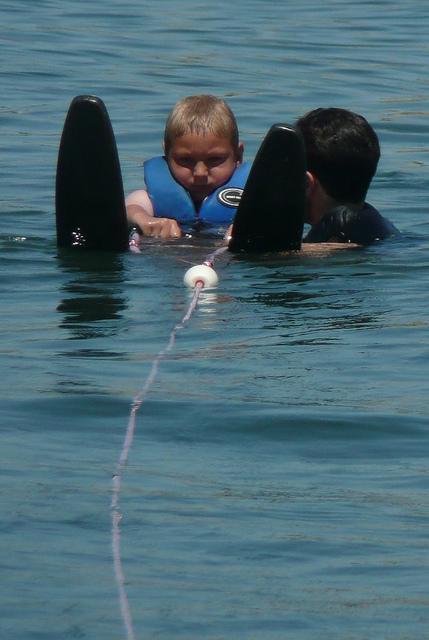How many people can be seen?
Give a very brief answer. 2. 